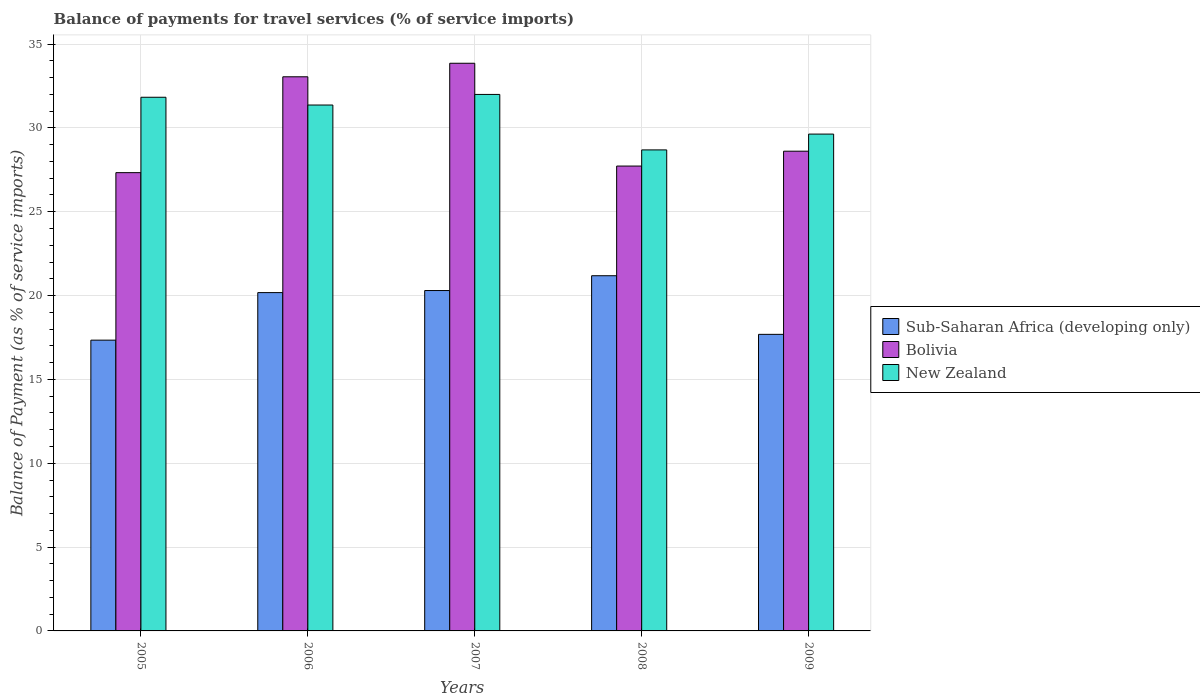How many different coloured bars are there?
Ensure brevity in your answer.  3. Are the number of bars per tick equal to the number of legend labels?
Make the answer very short. Yes. Are the number of bars on each tick of the X-axis equal?
Ensure brevity in your answer.  Yes. How many bars are there on the 5th tick from the left?
Give a very brief answer. 3. What is the label of the 3rd group of bars from the left?
Provide a succinct answer. 2007. What is the balance of payments for travel services in New Zealand in 2009?
Offer a terse response. 29.63. Across all years, what is the maximum balance of payments for travel services in New Zealand?
Offer a terse response. 32. Across all years, what is the minimum balance of payments for travel services in New Zealand?
Your answer should be very brief. 28.69. In which year was the balance of payments for travel services in Bolivia minimum?
Provide a succinct answer. 2005. What is the total balance of payments for travel services in Sub-Saharan Africa (developing only) in the graph?
Provide a succinct answer. 96.69. What is the difference between the balance of payments for travel services in Sub-Saharan Africa (developing only) in 2005 and that in 2006?
Provide a short and direct response. -2.84. What is the difference between the balance of payments for travel services in Sub-Saharan Africa (developing only) in 2005 and the balance of payments for travel services in Bolivia in 2009?
Offer a very short reply. -11.27. What is the average balance of payments for travel services in New Zealand per year?
Your answer should be very brief. 30.7. In the year 2007, what is the difference between the balance of payments for travel services in New Zealand and balance of payments for travel services in Bolivia?
Ensure brevity in your answer.  -1.86. In how many years, is the balance of payments for travel services in Sub-Saharan Africa (developing only) greater than 2 %?
Keep it short and to the point. 5. What is the ratio of the balance of payments for travel services in New Zealand in 2005 to that in 2006?
Your answer should be compact. 1.01. Is the difference between the balance of payments for travel services in New Zealand in 2005 and 2007 greater than the difference between the balance of payments for travel services in Bolivia in 2005 and 2007?
Make the answer very short. Yes. What is the difference between the highest and the second highest balance of payments for travel services in Sub-Saharan Africa (developing only)?
Provide a succinct answer. 0.88. What is the difference between the highest and the lowest balance of payments for travel services in New Zealand?
Offer a very short reply. 3.31. In how many years, is the balance of payments for travel services in New Zealand greater than the average balance of payments for travel services in New Zealand taken over all years?
Make the answer very short. 3. What does the 3rd bar from the left in 2009 represents?
Provide a short and direct response. New Zealand. What does the 1st bar from the right in 2007 represents?
Provide a succinct answer. New Zealand. What is the difference between two consecutive major ticks on the Y-axis?
Offer a very short reply. 5. Are the values on the major ticks of Y-axis written in scientific E-notation?
Keep it short and to the point. No. Does the graph contain grids?
Give a very brief answer. Yes. How many legend labels are there?
Ensure brevity in your answer.  3. What is the title of the graph?
Your answer should be compact. Balance of payments for travel services (% of service imports). What is the label or title of the Y-axis?
Give a very brief answer. Balance of Payment (as % of service imports). What is the Balance of Payment (as % of service imports) of Sub-Saharan Africa (developing only) in 2005?
Give a very brief answer. 17.34. What is the Balance of Payment (as % of service imports) of Bolivia in 2005?
Your response must be concise. 27.33. What is the Balance of Payment (as % of service imports) in New Zealand in 2005?
Your answer should be compact. 31.83. What is the Balance of Payment (as % of service imports) of Sub-Saharan Africa (developing only) in 2006?
Make the answer very short. 20.18. What is the Balance of Payment (as % of service imports) of Bolivia in 2006?
Provide a succinct answer. 33.05. What is the Balance of Payment (as % of service imports) of New Zealand in 2006?
Keep it short and to the point. 31.36. What is the Balance of Payment (as % of service imports) in Sub-Saharan Africa (developing only) in 2007?
Ensure brevity in your answer.  20.3. What is the Balance of Payment (as % of service imports) of Bolivia in 2007?
Provide a succinct answer. 33.86. What is the Balance of Payment (as % of service imports) in New Zealand in 2007?
Ensure brevity in your answer.  32. What is the Balance of Payment (as % of service imports) of Sub-Saharan Africa (developing only) in 2008?
Your answer should be compact. 21.18. What is the Balance of Payment (as % of service imports) of Bolivia in 2008?
Provide a short and direct response. 27.73. What is the Balance of Payment (as % of service imports) of New Zealand in 2008?
Offer a terse response. 28.69. What is the Balance of Payment (as % of service imports) in Sub-Saharan Africa (developing only) in 2009?
Make the answer very short. 17.69. What is the Balance of Payment (as % of service imports) in Bolivia in 2009?
Make the answer very short. 28.61. What is the Balance of Payment (as % of service imports) of New Zealand in 2009?
Ensure brevity in your answer.  29.63. Across all years, what is the maximum Balance of Payment (as % of service imports) in Sub-Saharan Africa (developing only)?
Offer a very short reply. 21.18. Across all years, what is the maximum Balance of Payment (as % of service imports) in Bolivia?
Provide a short and direct response. 33.86. Across all years, what is the maximum Balance of Payment (as % of service imports) in New Zealand?
Your answer should be compact. 32. Across all years, what is the minimum Balance of Payment (as % of service imports) of Sub-Saharan Africa (developing only)?
Your answer should be very brief. 17.34. Across all years, what is the minimum Balance of Payment (as % of service imports) of Bolivia?
Make the answer very short. 27.33. Across all years, what is the minimum Balance of Payment (as % of service imports) in New Zealand?
Provide a succinct answer. 28.69. What is the total Balance of Payment (as % of service imports) of Sub-Saharan Africa (developing only) in the graph?
Your answer should be compact. 96.69. What is the total Balance of Payment (as % of service imports) of Bolivia in the graph?
Ensure brevity in your answer.  150.57. What is the total Balance of Payment (as % of service imports) of New Zealand in the graph?
Provide a succinct answer. 153.51. What is the difference between the Balance of Payment (as % of service imports) in Sub-Saharan Africa (developing only) in 2005 and that in 2006?
Your answer should be very brief. -2.84. What is the difference between the Balance of Payment (as % of service imports) of Bolivia in 2005 and that in 2006?
Give a very brief answer. -5.72. What is the difference between the Balance of Payment (as % of service imports) of New Zealand in 2005 and that in 2006?
Give a very brief answer. 0.46. What is the difference between the Balance of Payment (as % of service imports) of Sub-Saharan Africa (developing only) in 2005 and that in 2007?
Provide a succinct answer. -2.96. What is the difference between the Balance of Payment (as % of service imports) of Bolivia in 2005 and that in 2007?
Offer a very short reply. -6.52. What is the difference between the Balance of Payment (as % of service imports) in New Zealand in 2005 and that in 2007?
Give a very brief answer. -0.17. What is the difference between the Balance of Payment (as % of service imports) of Sub-Saharan Africa (developing only) in 2005 and that in 2008?
Provide a short and direct response. -3.84. What is the difference between the Balance of Payment (as % of service imports) of Bolivia in 2005 and that in 2008?
Provide a succinct answer. -0.39. What is the difference between the Balance of Payment (as % of service imports) of New Zealand in 2005 and that in 2008?
Keep it short and to the point. 3.14. What is the difference between the Balance of Payment (as % of service imports) of Sub-Saharan Africa (developing only) in 2005 and that in 2009?
Your answer should be compact. -0.35. What is the difference between the Balance of Payment (as % of service imports) in Bolivia in 2005 and that in 2009?
Make the answer very short. -1.28. What is the difference between the Balance of Payment (as % of service imports) of New Zealand in 2005 and that in 2009?
Your response must be concise. 2.2. What is the difference between the Balance of Payment (as % of service imports) in Sub-Saharan Africa (developing only) in 2006 and that in 2007?
Provide a succinct answer. -0.12. What is the difference between the Balance of Payment (as % of service imports) of Bolivia in 2006 and that in 2007?
Give a very brief answer. -0.81. What is the difference between the Balance of Payment (as % of service imports) in New Zealand in 2006 and that in 2007?
Your answer should be compact. -0.63. What is the difference between the Balance of Payment (as % of service imports) in Sub-Saharan Africa (developing only) in 2006 and that in 2008?
Give a very brief answer. -1.01. What is the difference between the Balance of Payment (as % of service imports) in Bolivia in 2006 and that in 2008?
Your answer should be compact. 5.32. What is the difference between the Balance of Payment (as % of service imports) of New Zealand in 2006 and that in 2008?
Keep it short and to the point. 2.68. What is the difference between the Balance of Payment (as % of service imports) of Sub-Saharan Africa (developing only) in 2006 and that in 2009?
Give a very brief answer. 2.49. What is the difference between the Balance of Payment (as % of service imports) of Bolivia in 2006 and that in 2009?
Give a very brief answer. 4.44. What is the difference between the Balance of Payment (as % of service imports) of New Zealand in 2006 and that in 2009?
Make the answer very short. 1.73. What is the difference between the Balance of Payment (as % of service imports) in Sub-Saharan Africa (developing only) in 2007 and that in 2008?
Provide a succinct answer. -0.88. What is the difference between the Balance of Payment (as % of service imports) of Bolivia in 2007 and that in 2008?
Your answer should be very brief. 6.13. What is the difference between the Balance of Payment (as % of service imports) of New Zealand in 2007 and that in 2008?
Your response must be concise. 3.31. What is the difference between the Balance of Payment (as % of service imports) of Sub-Saharan Africa (developing only) in 2007 and that in 2009?
Provide a succinct answer. 2.61. What is the difference between the Balance of Payment (as % of service imports) in Bolivia in 2007 and that in 2009?
Provide a succinct answer. 5.24. What is the difference between the Balance of Payment (as % of service imports) of New Zealand in 2007 and that in 2009?
Keep it short and to the point. 2.37. What is the difference between the Balance of Payment (as % of service imports) in Sub-Saharan Africa (developing only) in 2008 and that in 2009?
Offer a very short reply. 3.5. What is the difference between the Balance of Payment (as % of service imports) in Bolivia in 2008 and that in 2009?
Your response must be concise. -0.89. What is the difference between the Balance of Payment (as % of service imports) in New Zealand in 2008 and that in 2009?
Provide a short and direct response. -0.94. What is the difference between the Balance of Payment (as % of service imports) in Sub-Saharan Africa (developing only) in 2005 and the Balance of Payment (as % of service imports) in Bolivia in 2006?
Give a very brief answer. -15.71. What is the difference between the Balance of Payment (as % of service imports) of Sub-Saharan Africa (developing only) in 2005 and the Balance of Payment (as % of service imports) of New Zealand in 2006?
Provide a succinct answer. -14.02. What is the difference between the Balance of Payment (as % of service imports) of Bolivia in 2005 and the Balance of Payment (as % of service imports) of New Zealand in 2006?
Provide a succinct answer. -4.03. What is the difference between the Balance of Payment (as % of service imports) in Sub-Saharan Africa (developing only) in 2005 and the Balance of Payment (as % of service imports) in Bolivia in 2007?
Make the answer very short. -16.51. What is the difference between the Balance of Payment (as % of service imports) of Sub-Saharan Africa (developing only) in 2005 and the Balance of Payment (as % of service imports) of New Zealand in 2007?
Your answer should be compact. -14.65. What is the difference between the Balance of Payment (as % of service imports) in Bolivia in 2005 and the Balance of Payment (as % of service imports) in New Zealand in 2007?
Give a very brief answer. -4.66. What is the difference between the Balance of Payment (as % of service imports) of Sub-Saharan Africa (developing only) in 2005 and the Balance of Payment (as % of service imports) of Bolivia in 2008?
Make the answer very short. -10.38. What is the difference between the Balance of Payment (as % of service imports) of Sub-Saharan Africa (developing only) in 2005 and the Balance of Payment (as % of service imports) of New Zealand in 2008?
Offer a very short reply. -11.35. What is the difference between the Balance of Payment (as % of service imports) in Bolivia in 2005 and the Balance of Payment (as % of service imports) in New Zealand in 2008?
Your response must be concise. -1.36. What is the difference between the Balance of Payment (as % of service imports) of Sub-Saharan Africa (developing only) in 2005 and the Balance of Payment (as % of service imports) of Bolivia in 2009?
Offer a very short reply. -11.27. What is the difference between the Balance of Payment (as % of service imports) in Sub-Saharan Africa (developing only) in 2005 and the Balance of Payment (as % of service imports) in New Zealand in 2009?
Keep it short and to the point. -12.29. What is the difference between the Balance of Payment (as % of service imports) of Bolivia in 2005 and the Balance of Payment (as % of service imports) of New Zealand in 2009?
Your answer should be very brief. -2.3. What is the difference between the Balance of Payment (as % of service imports) of Sub-Saharan Africa (developing only) in 2006 and the Balance of Payment (as % of service imports) of Bolivia in 2007?
Offer a very short reply. -13.68. What is the difference between the Balance of Payment (as % of service imports) in Sub-Saharan Africa (developing only) in 2006 and the Balance of Payment (as % of service imports) in New Zealand in 2007?
Offer a terse response. -11.82. What is the difference between the Balance of Payment (as % of service imports) in Bolivia in 2006 and the Balance of Payment (as % of service imports) in New Zealand in 2007?
Keep it short and to the point. 1.05. What is the difference between the Balance of Payment (as % of service imports) of Sub-Saharan Africa (developing only) in 2006 and the Balance of Payment (as % of service imports) of Bolivia in 2008?
Offer a very short reply. -7.55. What is the difference between the Balance of Payment (as % of service imports) of Sub-Saharan Africa (developing only) in 2006 and the Balance of Payment (as % of service imports) of New Zealand in 2008?
Your response must be concise. -8.51. What is the difference between the Balance of Payment (as % of service imports) of Bolivia in 2006 and the Balance of Payment (as % of service imports) of New Zealand in 2008?
Offer a very short reply. 4.36. What is the difference between the Balance of Payment (as % of service imports) of Sub-Saharan Africa (developing only) in 2006 and the Balance of Payment (as % of service imports) of Bolivia in 2009?
Give a very brief answer. -8.43. What is the difference between the Balance of Payment (as % of service imports) of Sub-Saharan Africa (developing only) in 2006 and the Balance of Payment (as % of service imports) of New Zealand in 2009?
Keep it short and to the point. -9.45. What is the difference between the Balance of Payment (as % of service imports) of Bolivia in 2006 and the Balance of Payment (as % of service imports) of New Zealand in 2009?
Keep it short and to the point. 3.42. What is the difference between the Balance of Payment (as % of service imports) in Sub-Saharan Africa (developing only) in 2007 and the Balance of Payment (as % of service imports) in Bolivia in 2008?
Your answer should be compact. -7.42. What is the difference between the Balance of Payment (as % of service imports) in Sub-Saharan Africa (developing only) in 2007 and the Balance of Payment (as % of service imports) in New Zealand in 2008?
Your answer should be very brief. -8.39. What is the difference between the Balance of Payment (as % of service imports) of Bolivia in 2007 and the Balance of Payment (as % of service imports) of New Zealand in 2008?
Ensure brevity in your answer.  5.17. What is the difference between the Balance of Payment (as % of service imports) in Sub-Saharan Africa (developing only) in 2007 and the Balance of Payment (as % of service imports) in Bolivia in 2009?
Your response must be concise. -8.31. What is the difference between the Balance of Payment (as % of service imports) of Sub-Saharan Africa (developing only) in 2007 and the Balance of Payment (as % of service imports) of New Zealand in 2009?
Provide a succinct answer. -9.33. What is the difference between the Balance of Payment (as % of service imports) in Bolivia in 2007 and the Balance of Payment (as % of service imports) in New Zealand in 2009?
Offer a very short reply. 4.22. What is the difference between the Balance of Payment (as % of service imports) of Sub-Saharan Africa (developing only) in 2008 and the Balance of Payment (as % of service imports) of Bolivia in 2009?
Provide a short and direct response. -7.43. What is the difference between the Balance of Payment (as % of service imports) in Sub-Saharan Africa (developing only) in 2008 and the Balance of Payment (as % of service imports) in New Zealand in 2009?
Offer a terse response. -8.45. What is the difference between the Balance of Payment (as % of service imports) of Bolivia in 2008 and the Balance of Payment (as % of service imports) of New Zealand in 2009?
Offer a terse response. -1.91. What is the average Balance of Payment (as % of service imports) in Sub-Saharan Africa (developing only) per year?
Provide a succinct answer. 19.34. What is the average Balance of Payment (as % of service imports) in Bolivia per year?
Provide a short and direct response. 30.11. What is the average Balance of Payment (as % of service imports) of New Zealand per year?
Your answer should be compact. 30.7. In the year 2005, what is the difference between the Balance of Payment (as % of service imports) in Sub-Saharan Africa (developing only) and Balance of Payment (as % of service imports) in Bolivia?
Provide a succinct answer. -9.99. In the year 2005, what is the difference between the Balance of Payment (as % of service imports) in Sub-Saharan Africa (developing only) and Balance of Payment (as % of service imports) in New Zealand?
Your answer should be very brief. -14.49. In the year 2005, what is the difference between the Balance of Payment (as % of service imports) of Bolivia and Balance of Payment (as % of service imports) of New Zealand?
Your answer should be very brief. -4.5. In the year 2006, what is the difference between the Balance of Payment (as % of service imports) in Sub-Saharan Africa (developing only) and Balance of Payment (as % of service imports) in Bolivia?
Provide a short and direct response. -12.87. In the year 2006, what is the difference between the Balance of Payment (as % of service imports) in Sub-Saharan Africa (developing only) and Balance of Payment (as % of service imports) in New Zealand?
Offer a terse response. -11.19. In the year 2006, what is the difference between the Balance of Payment (as % of service imports) in Bolivia and Balance of Payment (as % of service imports) in New Zealand?
Give a very brief answer. 1.68. In the year 2007, what is the difference between the Balance of Payment (as % of service imports) of Sub-Saharan Africa (developing only) and Balance of Payment (as % of service imports) of Bolivia?
Your answer should be very brief. -13.56. In the year 2007, what is the difference between the Balance of Payment (as % of service imports) in Sub-Saharan Africa (developing only) and Balance of Payment (as % of service imports) in New Zealand?
Keep it short and to the point. -11.7. In the year 2007, what is the difference between the Balance of Payment (as % of service imports) of Bolivia and Balance of Payment (as % of service imports) of New Zealand?
Make the answer very short. 1.86. In the year 2008, what is the difference between the Balance of Payment (as % of service imports) of Sub-Saharan Africa (developing only) and Balance of Payment (as % of service imports) of Bolivia?
Give a very brief answer. -6.54. In the year 2008, what is the difference between the Balance of Payment (as % of service imports) in Sub-Saharan Africa (developing only) and Balance of Payment (as % of service imports) in New Zealand?
Your response must be concise. -7.5. In the year 2008, what is the difference between the Balance of Payment (as % of service imports) in Bolivia and Balance of Payment (as % of service imports) in New Zealand?
Your answer should be compact. -0.96. In the year 2009, what is the difference between the Balance of Payment (as % of service imports) in Sub-Saharan Africa (developing only) and Balance of Payment (as % of service imports) in Bolivia?
Give a very brief answer. -10.92. In the year 2009, what is the difference between the Balance of Payment (as % of service imports) in Sub-Saharan Africa (developing only) and Balance of Payment (as % of service imports) in New Zealand?
Ensure brevity in your answer.  -11.94. In the year 2009, what is the difference between the Balance of Payment (as % of service imports) in Bolivia and Balance of Payment (as % of service imports) in New Zealand?
Make the answer very short. -1.02. What is the ratio of the Balance of Payment (as % of service imports) in Sub-Saharan Africa (developing only) in 2005 to that in 2006?
Provide a short and direct response. 0.86. What is the ratio of the Balance of Payment (as % of service imports) of Bolivia in 2005 to that in 2006?
Provide a short and direct response. 0.83. What is the ratio of the Balance of Payment (as % of service imports) in New Zealand in 2005 to that in 2006?
Make the answer very short. 1.01. What is the ratio of the Balance of Payment (as % of service imports) of Sub-Saharan Africa (developing only) in 2005 to that in 2007?
Offer a terse response. 0.85. What is the ratio of the Balance of Payment (as % of service imports) of Bolivia in 2005 to that in 2007?
Offer a terse response. 0.81. What is the ratio of the Balance of Payment (as % of service imports) in New Zealand in 2005 to that in 2007?
Your answer should be very brief. 0.99. What is the ratio of the Balance of Payment (as % of service imports) in Sub-Saharan Africa (developing only) in 2005 to that in 2008?
Offer a very short reply. 0.82. What is the ratio of the Balance of Payment (as % of service imports) in Bolivia in 2005 to that in 2008?
Give a very brief answer. 0.99. What is the ratio of the Balance of Payment (as % of service imports) in New Zealand in 2005 to that in 2008?
Your response must be concise. 1.11. What is the ratio of the Balance of Payment (as % of service imports) of Sub-Saharan Africa (developing only) in 2005 to that in 2009?
Provide a short and direct response. 0.98. What is the ratio of the Balance of Payment (as % of service imports) of Bolivia in 2005 to that in 2009?
Provide a succinct answer. 0.96. What is the ratio of the Balance of Payment (as % of service imports) in New Zealand in 2005 to that in 2009?
Provide a short and direct response. 1.07. What is the ratio of the Balance of Payment (as % of service imports) in Sub-Saharan Africa (developing only) in 2006 to that in 2007?
Make the answer very short. 0.99. What is the ratio of the Balance of Payment (as % of service imports) of Bolivia in 2006 to that in 2007?
Give a very brief answer. 0.98. What is the ratio of the Balance of Payment (as % of service imports) in New Zealand in 2006 to that in 2007?
Give a very brief answer. 0.98. What is the ratio of the Balance of Payment (as % of service imports) of Sub-Saharan Africa (developing only) in 2006 to that in 2008?
Provide a short and direct response. 0.95. What is the ratio of the Balance of Payment (as % of service imports) of Bolivia in 2006 to that in 2008?
Your answer should be compact. 1.19. What is the ratio of the Balance of Payment (as % of service imports) of New Zealand in 2006 to that in 2008?
Give a very brief answer. 1.09. What is the ratio of the Balance of Payment (as % of service imports) of Sub-Saharan Africa (developing only) in 2006 to that in 2009?
Your response must be concise. 1.14. What is the ratio of the Balance of Payment (as % of service imports) of Bolivia in 2006 to that in 2009?
Your answer should be compact. 1.16. What is the ratio of the Balance of Payment (as % of service imports) in New Zealand in 2006 to that in 2009?
Keep it short and to the point. 1.06. What is the ratio of the Balance of Payment (as % of service imports) of Sub-Saharan Africa (developing only) in 2007 to that in 2008?
Your answer should be compact. 0.96. What is the ratio of the Balance of Payment (as % of service imports) of Bolivia in 2007 to that in 2008?
Offer a terse response. 1.22. What is the ratio of the Balance of Payment (as % of service imports) in New Zealand in 2007 to that in 2008?
Give a very brief answer. 1.12. What is the ratio of the Balance of Payment (as % of service imports) in Sub-Saharan Africa (developing only) in 2007 to that in 2009?
Your answer should be very brief. 1.15. What is the ratio of the Balance of Payment (as % of service imports) of Bolivia in 2007 to that in 2009?
Ensure brevity in your answer.  1.18. What is the ratio of the Balance of Payment (as % of service imports) of New Zealand in 2007 to that in 2009?
Keep it short and to the point. 1.08. What is the ratio of the Balance of Payment (as % of service imports) in Sub-Saharan Africa (developing only) in 2008 to that in 2009?
Give a very brief answer. 1.2. What is the ratio of the Balance of Payment (as % of service imports) of Bolivia in 2008 to that in 2009?
Your answer should be compact. 0.97. What is the ratio of the Balance of Payment (as % of service imports) of New Zealand in 2008 to that in 2009?
Your response must be concise. 0.97. What is the difference between the highest and the second highest Balance of Payment (as % of service imports) in Sub-Saharan Africa (developing only)?
Keep it short and to the point. 0.88. What is the difference between the highest and the second highest Balance of Payment (as % of service imports) in Bolivia?
Give a very brief answer. 0.81. What is the difference between the highest and the second highest Balance of Payment (as % of service imports) in New Zealand?
Ensure brevity in your answer.  0.17. What is the difference between the highest and the lowest Balance of Payment (as % of service imports) in Sub-Saharan Africa (developing only)?
Make the answer very short. 3.84. What is the difference between the highest and the lowest Balance of Payment (as % of service imports) of Bolivia?
Your answer should be compact. 6.52. What is the difference between the highest and the lowest Balance of Payment (as % of service imports) in New Zealand?
Provide a succinct answer. 3.31. 